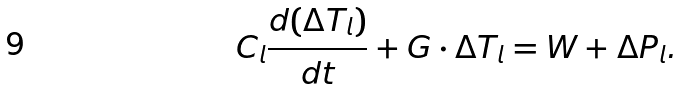Convert formula to latex. <formula><loc_0><loc_0><loc_500><loc_500>C _ { l } \frac { d ( \Delta T _ { l } ) } { d t } + G \cdot \Delta T _ { l } = W + \Delta P _ { l } .</formula> 